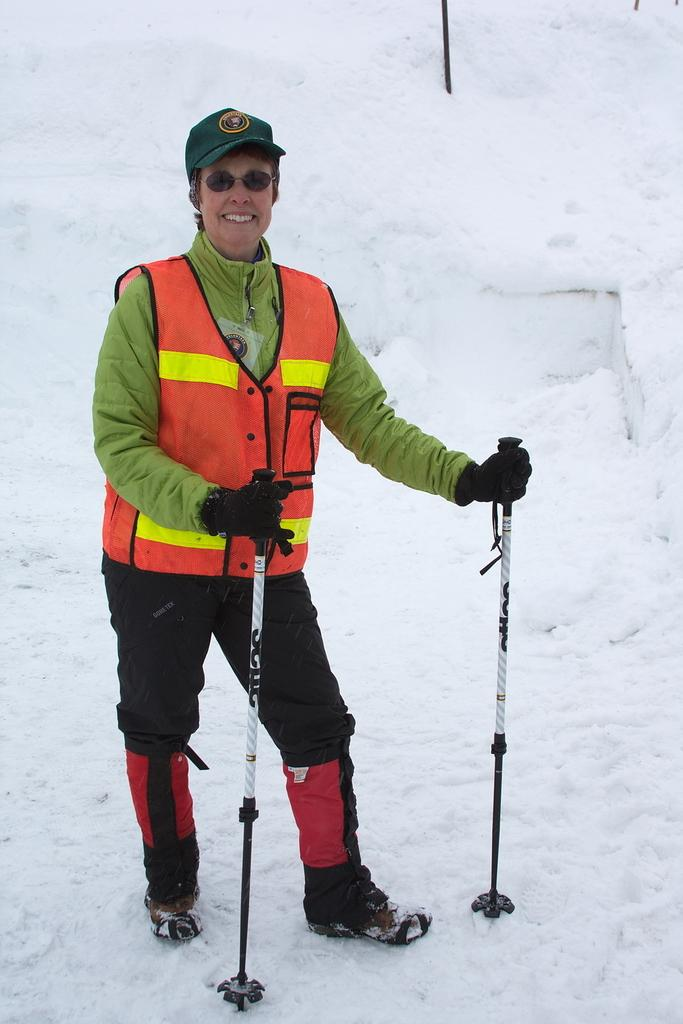What is the main subject of the image? There is a person in the image. What is the person holding in the image? The person is holding sticks. Can you describe the setting of the image? The image shows a person holding sticks, and there are sticks on the snow in the background. What type of experience does the person's father have with the sticks in the image? There is no information about the person's father or any experience with the sticks in the image. Can you tell me how many cats are visible in the image? There are no cats present in the image. 